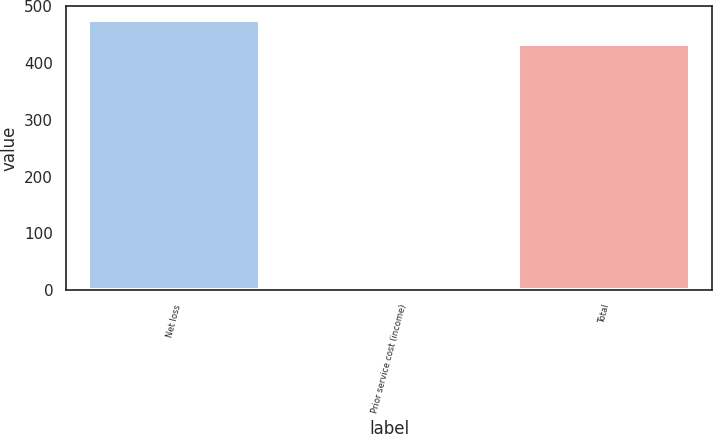<chart> <loc_0><loc_0><loc_500><loc_500><bar_chart><fcel>Net loss<fcel>Prior service cost (income)<fcel>Total<nl><fcel>476.3<fcel>7<fcel>433<nl></chart> 